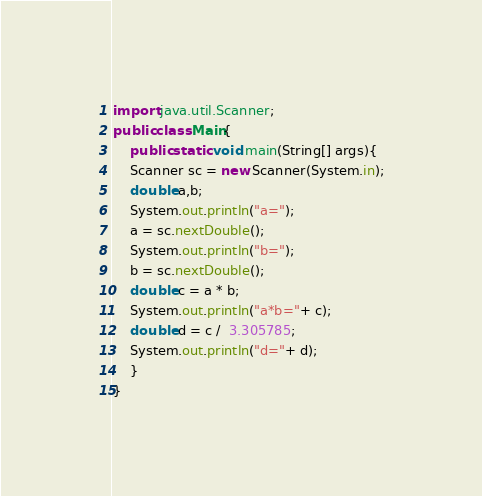<code> <loc_0><loc_0><loc_500><loc_500><_Java_>import java.util.Scanner;
public class Main{
    public static void main(String[] args){
    Scanner sc = new Scanner(System.in);
    double a,b;
    System.out.println("a=");
    a = sc.nextDouble();
    System.out.println("b=");
    b = sc.nextDouble();
    double c = a * b;
    System.out.println("a*b="+ c);
    double d = c /  3.305785;
    System.out.println("d="+ d);
    }
}
</code> 